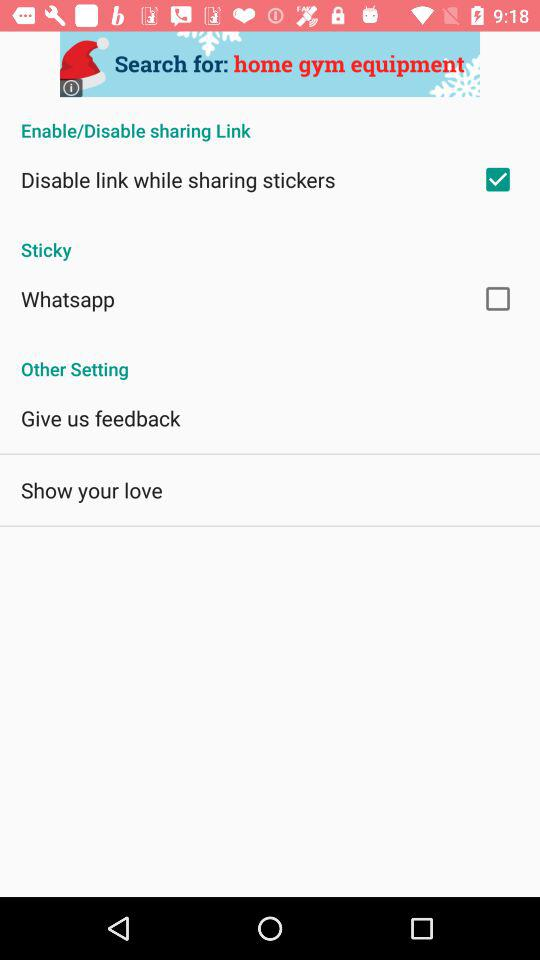What is the status of "Disable link while sharing stickers"? The status of "Disable link while sharing stickers" is "on". 